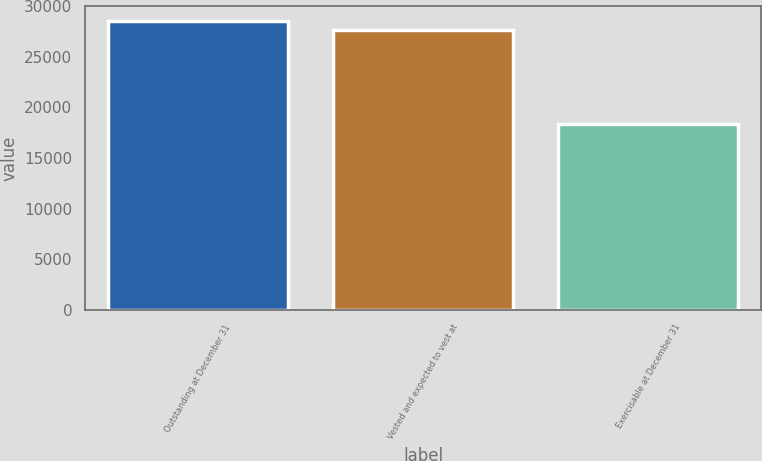Convert chart to OTSL. <chart><loc_0><loc_0><loc_500><loc_500><bar_chart><fcel>Outstanding at December 31<fcel>Vested and expected to vest at<fcel>Exercisable at December 31<nl><fcel>28588.6<fcel>27616<fcel>18403<nl></chart> 